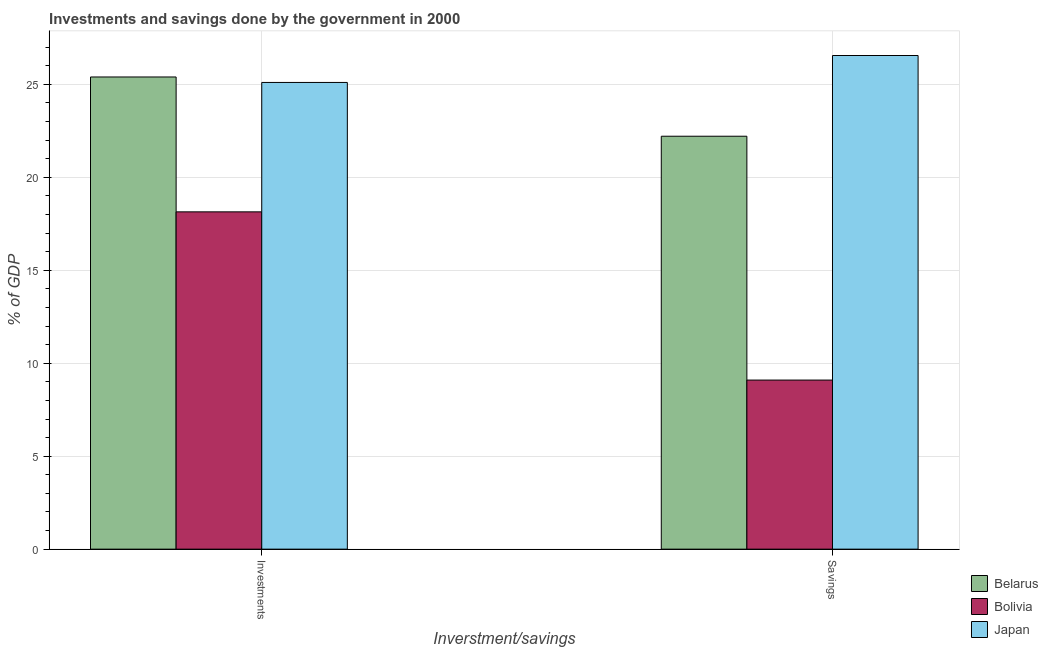How many groups of bars are there?
Make the answer very short. 2. Are the number of bars per tick equal to the number of legend labels?
Provide a short and direct response. Yes. How many bars are there on the 1st tick from the left?
Ensure brevity in your answer.  3. How many bars are there on the 1st tick from the right?
Give a very brief answer. 3. What is the label of the 2nd group of bars from the left?
Give a very brief answer. Savings. What is the savings of government in Belarus?
Make the answer very short. 22.21. Across all countries, what is the maximum savings of government?
Offer a very short reply. 26.55. Across all countries, what is the minimum investments of government?
Provide a short and direct response. 18.14. In which country was the savings of government maximum?
Offer a terse response. Japan. What is the total savings of government in the graph?
Your response must be concise. 57.86. What is the difference between the investments of government in Belarus and that in Bolivia?
Offer a very short reply. 7.26. What is the difference between the investments of government in Bolivia and the savings of government in Japan?
Your response must be concise. -8.41. What is the average investments of government per country?
Provide a short and direct response. 22.88. What is the difference between the savings of government and investments of government in Belarus?
Provide a short and direct response. -3.19. In how many countries, is the investments of government greater than 26 %?
Keep it short and to the point. 0. What is the ratio of the investments of government in Japan to that in Belarus?
Make the answer very short. 0.99. Is the investments of government in Bolivia less than that in Japan?
Your answer should be very brief. Yes. In how many countries, is the savings of government greater than the average savings of government taken over all countries?
Your response must be concise. 2. What does the 2nd bar from the left in Savings represents?
Offer a very short reply. Bolivia. How many bars are there?
Make the answer very short. 6. Are all the bars in the graph horizontal?
Ensure brevity in your answer.  No. How many countries are there in the graph?
Your answer should be very brief. 3. Are the values on the major ticks of Y-axis written in scientific E-notation?
Make the answer very short. No. How many legend labels are there?
Your response must be concise. 3. What is the title of the graph?
Provide a short and direct response. Investments and savings done by the government in 2000. Does "Spain" appear as one of the legend labels in the graph?
Ensure brevity in your answer.  No. What is the label or title of the X-axis?
Make the answer very short. Inverstment/savings. What is the label or title of the Y-axis?
Your answer should be very brief. % of GDP. What is the % of GDP in Belarus in Investments?
Keep it short and to the point. 25.4. What is the % of GDP of Bolivia in Investments?
Your answer should be compact. 18.14. What is the % of GDP of Japan in Investments?
Offer a very short reply. 25.1. What is the % of GDP in Belarus in Savings?
Provide a succinct answer. 22.21. What is the % of GDP in Bolivia in Savings?
Provide a short and direct response. 9.1. What is the % of GDP of Japan in Savings?
Give a very brief answer. 26.55. Across all Inverstment/savings, what is the maximum % of GDP in Belarus?
Ensure brevity in your answer.  25.4. Across all Inverstment/savings, what is the maximum % of GDP of Bolivia?
Ensure brevity in your answer.  18.14. Across all Inverstment/savings, what is the maximum % of GDP of Japan?
Your answer should be very brief. 26.55. Across all Inverstment/savings, what is the minimum % of GDP in Belarus?
Make the answer very short. 22.21. Across all Inverstment/savings, what is the minimum % of GDP in Bolivia?
Make the answer very short. 9.1. Across all Inverstment/savings, what is the minimum % of GDP in Japan?
Your response must be concise. 25.1. What is the total % of GDP in Belarus in the graph?
Your answer should be very brief. 47.61. What is the total % of GDP of Bolivia in the graph?
Provide a succinct answer. 27.24. What is the total % of GDP in Japan in the graph?
Make the answer very short. 51.66. What is the difference between the % of GDP in Belarus in Investments and that in Savings?
Your answer should be compact. 3.19. What is the difference between the % of GDP of Bolivia in Investments and that in Savings?
Your answer should be very brief. 9.05. What is the difference between the % of GDP of Japan in Investments and that in Savings?
Provide a succinct answer. -1.45. What is the difference between the % of GDP of Belarus in Investments and the % of GDP of Bolivia in Savings?
Your answer should be very brief. 16.3. What is the difference between the % of GDP in Belarus in Investments and the % of GDP in Japan in Savings?
Give a very brief answer. -1.15. What is the difference between the % of GDP in Bolivia in Investments and the % of GDP in Japan in Savings?
Make the answer very short. -8.41. What is the average % of GDP of Belarus per Inverstment/savings?
Give a very brief answer. 23.8. What is the average % of GDP of Bolivia per Inverstment/savings?
Ensure brevity in your answer.  13.62. What is the average % of GDP of Japan per Inverstment/savings?
Keep it short and to the point. 25.83. What is the difference between the % of GDP of Belarus and % of GDP of Bolivia in Investments?
Offer a terse response. 7.26. What is the difference between the % of GDP of Belarus and % of GDP of Japan in Investments?
Provide a succinct answer. 0.29. What is the difference between the % of GDP in Bolivia and % of GDP in Japan in Investments?
Your response must be concise. -6.96. What is the difference between the % of GDP of Belarus and % of GDP of Bolivia in Savings?
Give a very brief answer. 13.12. What is the difference between the % of GDP in Belarus and % of GDP in Japan in Savings?
Make the answer very short. -4.34. What is the difference between the % of GDP of Bolivia and % of GDP of Japan in Savings?
Your answer should be compact. -17.46. What is the ratio of the % of GDP in Belarus in Investments to that in Savings?
Offer a terse response. 1.14. What is the ratio of the % of GDP in Bolivia in Investments to that in Savings?
Keep it short and to the point. 1.99. What is the ratio of the % of GDP of Japan in Investments to that in Savings?
Your response must be concise. 0.95. What is the difference between the highest and the second highest % of GDP of Belarus?
Offer a terse response. 3.19. What is the difference between the highest and the second highest % of GDP of Bolivia?
Provide a succinct answer. 9.05. What is the difference between the highest and the second highest % of GDP in Japan?
Provide a short and direct response. 1.45. What is the difference between the highest and the lowest % of GDP in Belarus?
Your answer should be very brief. 3.19. What is the difference between the highest and the lowest % of GDP of Bolivia?
Your response must be concise. 9.05. What is the difference between the highest and the lowest % of GDP of Japan?
Offer a terse response. 1.45. 